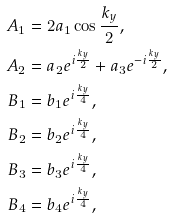Convert formula to latex. <formula><loc_0><loc_0><loc_500><loc_500>A _ { 1 } & = 2 a _ { 1 } \cos \frac { k _ { y } } { 2 } , \\ A _ { 2 } & = a _ { 2 } e ^ { i \frac { k _ { y } } { 2 } } + a _ { 3 } e ^ { - i \frac { k _ { y } } { 2 } } , \\ B _ { 1 } & = b _ { 1 } e ^ { i \frac { k _ { y } } { 4 } } , \\ B _ { 2 } & = b _ { 2 } e ^ { i \frac { k _ { y } } { 4 } } , \\ B _ { 3 } & = b _ { 3 } e ^ { i \frac { k _ { y } } { 4 } } , \\ B _ { 4 } & = b _ { 4 } e ^ { i \frac { k _ { y } } { 4 } } ,</formula> 